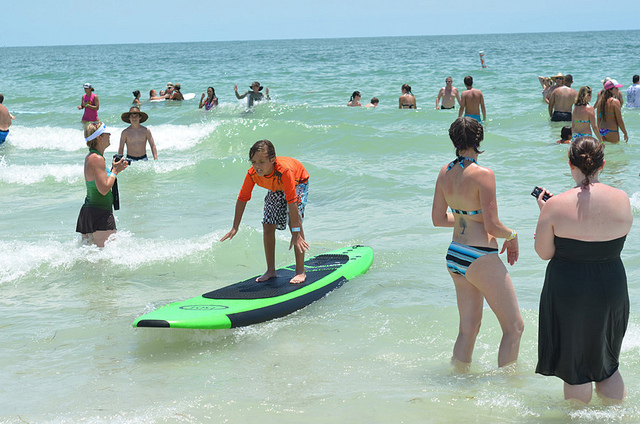How many surfboards are there? There is one surfboard in the image. 